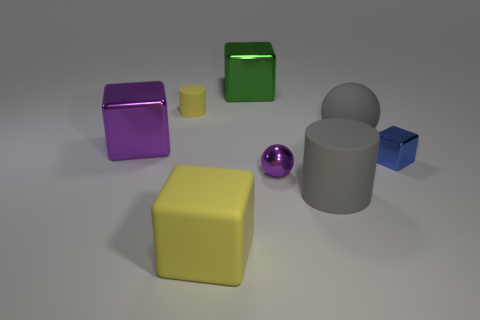Is the size of the gray rubber sphere the same as the purple metallic object to the right of the large yellow object?
Offer a terse response. No. Is the number of large things on the right side of the gray rubber cylinder the same as the number of spheres in front of the tiny ball?
Provide a short and direct response. No. There is a thing that is the same color as the large ball; what is its shape?
Provide a short and direct response. Cylinder. There is a large block on the left side of the tiny yellow rubber cylinder; what is it made of?
Your answer should be compact. Metal. Do the matte sphere and the gray matte cylinder have the same size?
Your answer should be compact. Yes. Is the number of small shiny blocks in front of the blue object greater than the number of big gray rubber things?
Offer a terse response. No. There is a gray cylinder that is made of the same material as the big ball; what is its size?
Your answer should be very brief. Large. There is a tiny yellow cylinder; are there any large green shiny things behind it?
Provide a succinct answer. Yes. Does the small purple metal object have the same shape as the small yellow object?
Provide a short and direct response. No. There is a gray thing behind the big block that is on the left side of the yellow thing on the left side of the big matte block; what size is it?
Provide a short and direct response. Large. 